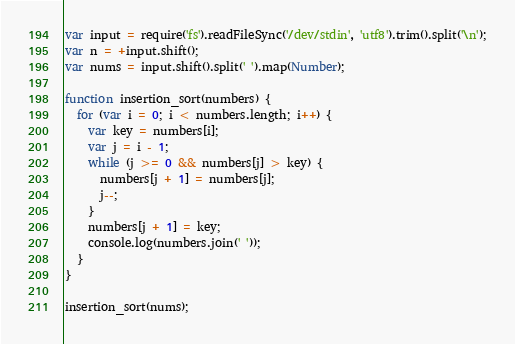<code> <loc_0><loc_0><loc_500><loc_500><_JavaScript_>var input = require('fs').readFileSync('/dev/stdin', 'utf8').trim().split('\n');
var n = +input.shift();
var nums = input.shift().split(' ').map(Number);

function insertion_sort(numbers) {
  for (var i = 0; i < numbers.length; i++) {
    var key = numbers[i];
    var j = i - 1;
    while (j >= 0 && numbers[j] > key) {
      numbers[j + 1] = numbers[j];
      j--;
    }
    numbers[j + 1] = key;
    console.log(numbers.join(' '));
  }
}

insertion_sort(nums);</code> 